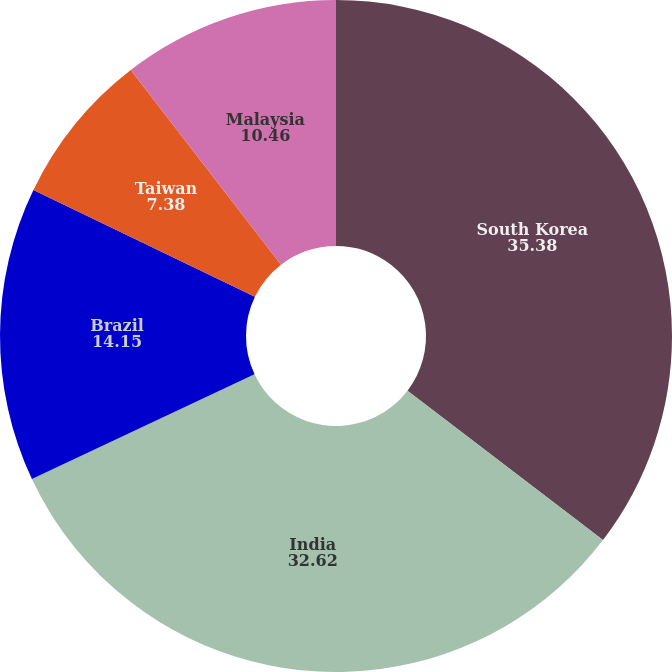Convert chart. <chart><loc_0><loc_0><loc_500><loc_500><pie_chart><fcel>South Korea<fcel>India<fcel>Brazil<fcel>Taiwan<fcel>Malaysia<nl><fcel>35.38%<fcel>32.62%<fcel>14.15%<fcel>7.38%<fcel>10.46%<nl></chart> 